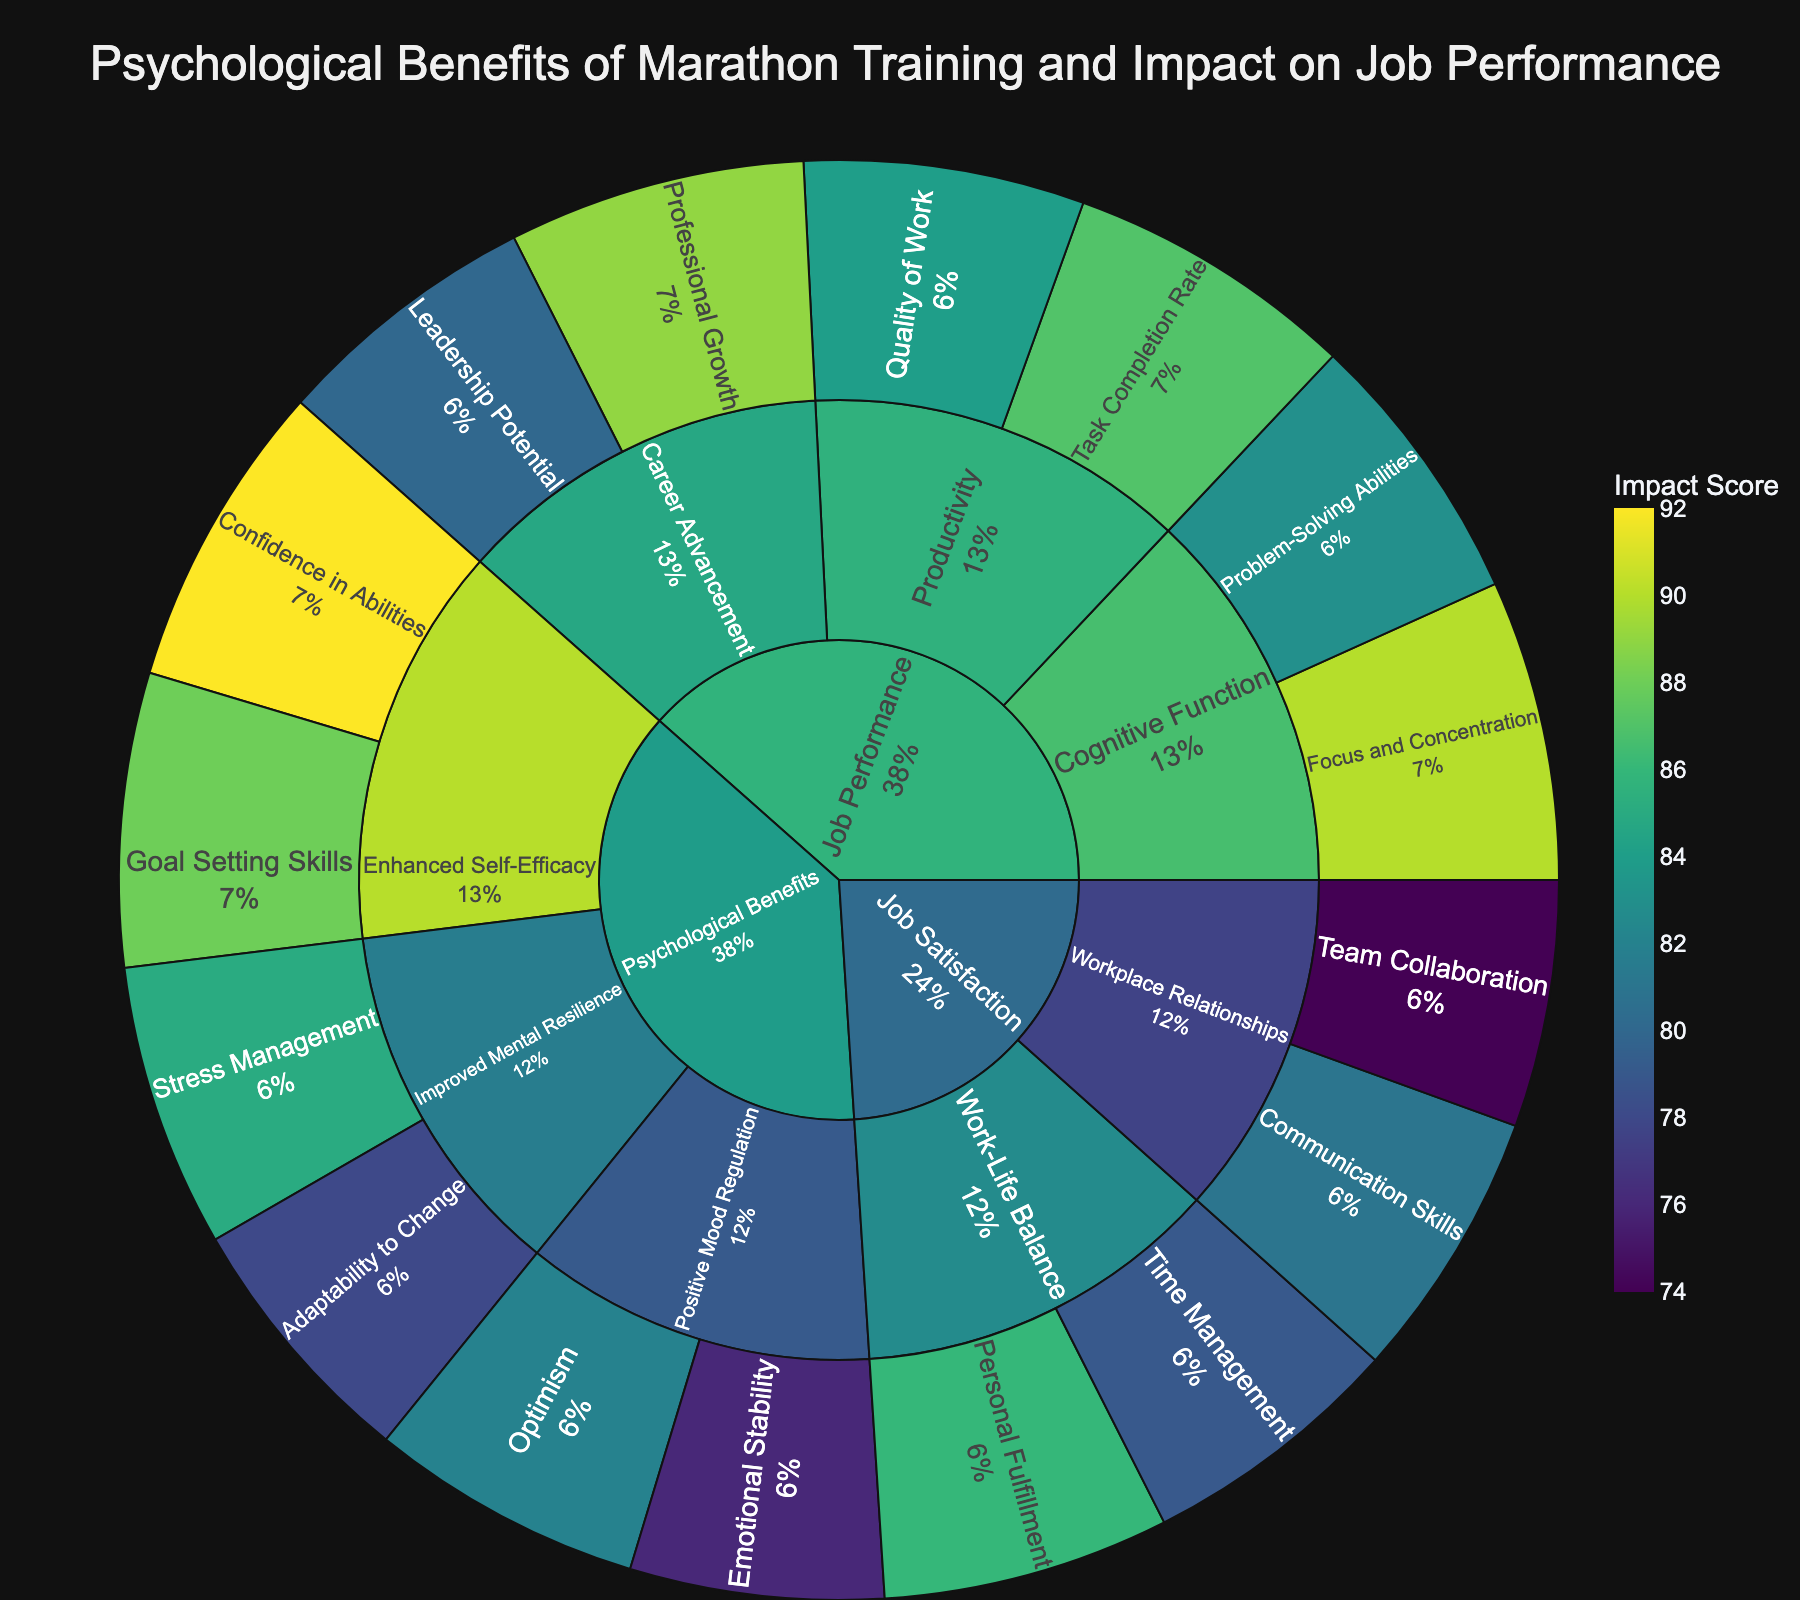What is the main title of the figure? The main title is always stated at the top of the figure. For this particular plot, it is clearly stated in the title section.
Answer: Psychological Benefits of Marathon Training and Impact on Job Performance Which aspect under "Improved Mental Resilience" has a higher impact score: "Stress Management" or "Adaptability to Change"? To find the answer, look under the "Improved Mental Resilience" subcategory and compare the values of "Stress Management" and "Adaptability to Change".
Answer: Stress Management What is the total impact score for "Positive Mood Regulation"? Add the values of the aspects under the "Positive Mood Regulation" subcategory: Emotional Stability (76) and Optimism (82).
Answer: 158 How does "Confidence in Abilities" compare to "Problem-Solving Abilities" in terms of impact? Compare the impact scores listed under "Confidence in Abilities" (92) and "Problem-Solving Abilities" (83).
Answer: Confidence in Abilities has a higher impact score Which subcategory under "Job Performance" has the highest impact score? Look at all the subcategories listed under "Job Performance" and identify the one with the highest value. Subcategories are Cognitive Function, Productivity, and Career Advancement.
Answer: Career Advancement What is the average impact score for aspects under "Work-Life Balance"? Add the impact scores for Time Management (79) and Personal Fulfillment (86), and then divide by 2 to find the average.
Answer: 82.5 Which aspect has a higher impact score: "Leadership Potential" or "Professional Growth"? Compare the impact scores for "Leadership Potential" (80) and "Professional Growth" (89) under the Career Advancement subcategory.
Answer: Professional Growth What is the sum of impact scores for all aspects under "Enhanced Self-Efficacy"? Add the impact scores for Confidence in Abilities (92) and Goal Setting Skills (88).
Answer: 180 Which subcategory under "Job Satisfaction" shows a higher impact score for "Personal Fulfillment"? Identify which subcategory includes "Personal Fulfillment" by checking the subcategory names.
Answer: Work-Life Balance In terms of "Task Completion Rate" and "Quality of Work", which one scores higher? Look under the "Productivity" subcategory and compare the impact scores for "Task Completion Rate" (87) and "Quality of Work" (84).
Answer: Task Completion Rate 